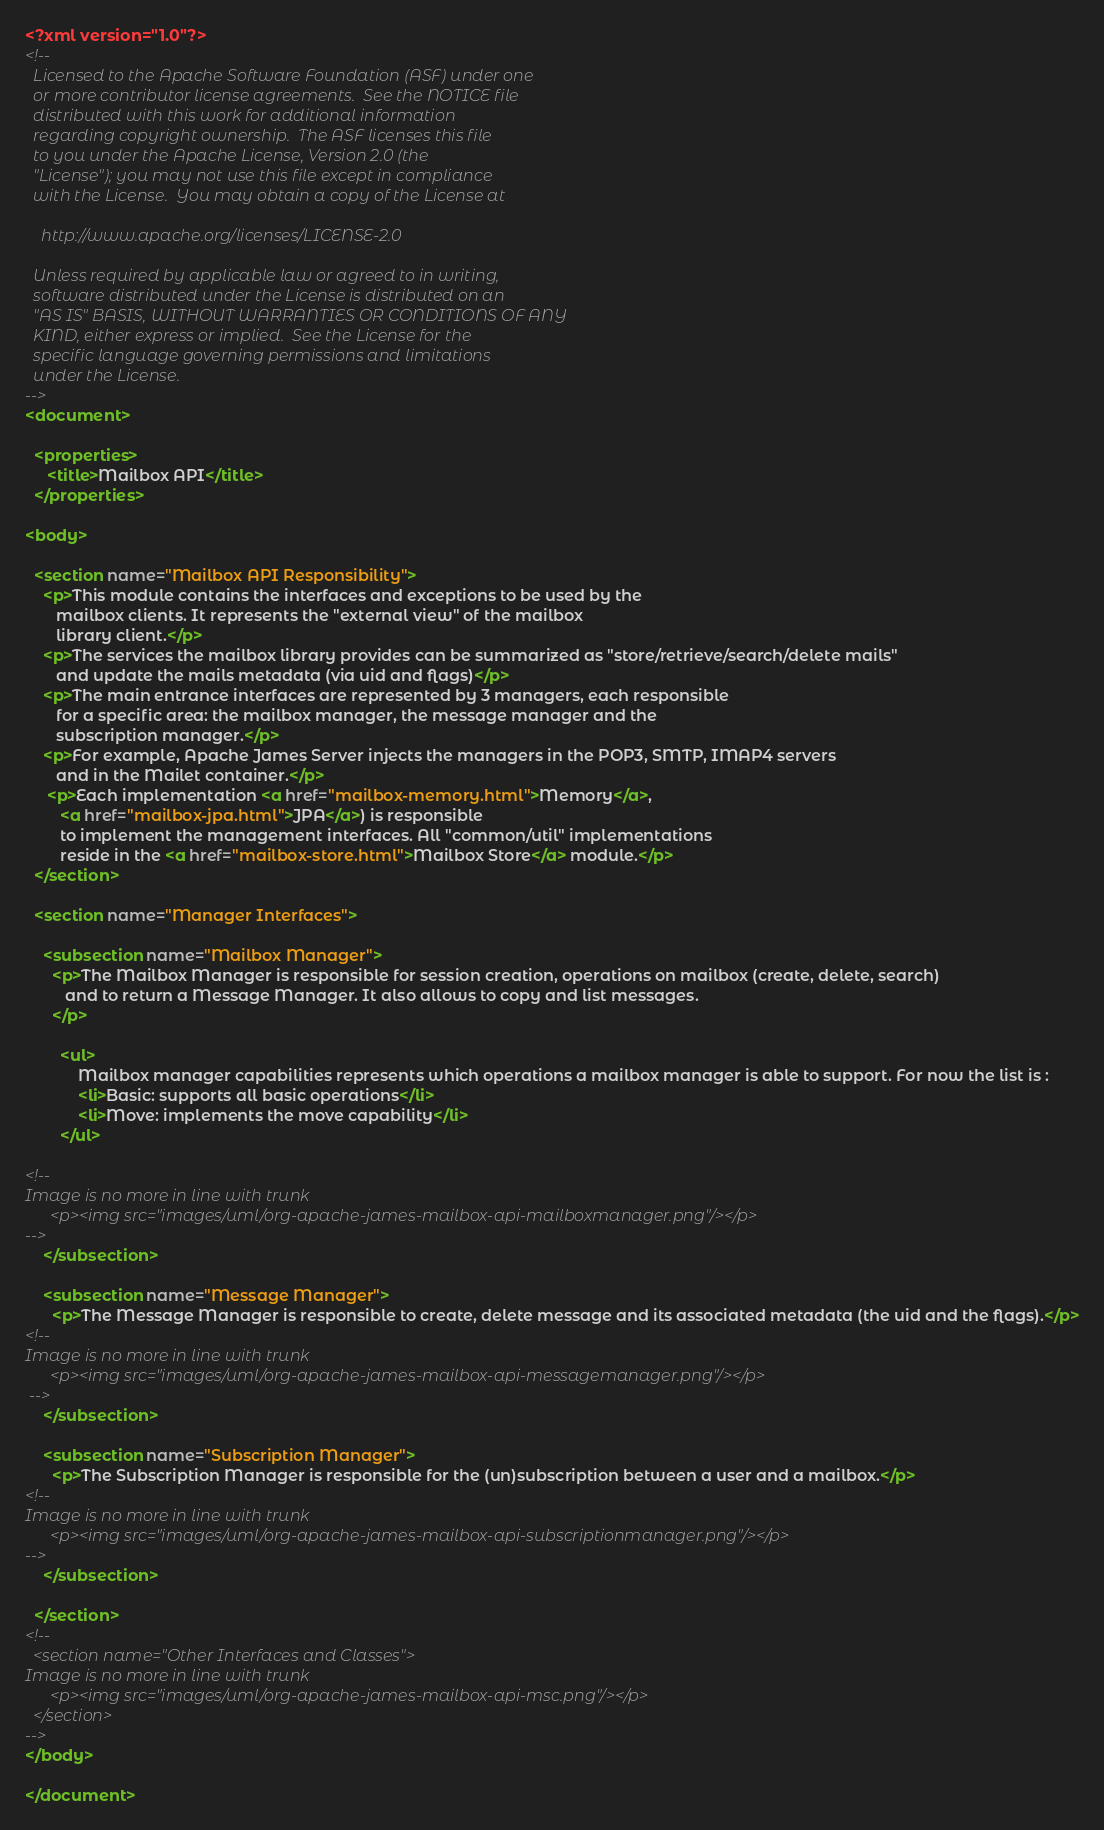<code> <loc_0><loc_0><loc_500><loc_500><_XML_><?xml version="1.0"?>
<!--
  Licensed to the Apache Software Foundation (ASF) under one
  or more contributor license agreements.  See the NOTICE file
  distributed with this work for additional information
  regarding copyright ownership.  The ASF licenses this file
  to you under the Apache License, Version 2.0 (the
  "License"); you may not use this file except in compliance
  with the License.  You may obtain a copy of the License at

    http://www.apache.org/licenses/LICENSE-2.0

  Unless required by applicable law or agreed to in writing,
  software distributed under the License is distributed on an
  "AS IS" BASIS, WITHOUT WARRANTIES OR CONDITIONS OF ANY
  KIND, either express or implied.  See the License for the
  specific language governing permissions and limitations
  under the License.    
-->
<document>

  <properties>
     <title>Mailbox API</title>
  </properties>

<body>

  <section name="Mailbox API Responsibility">
    <p>This module contains the interfaces and exceptions to be used by the 
       mailbox clients. It represents the "external view" of the mailbox
       library client.</p>
    <p>The services the mailbox library provides can be summarized as "store/retrieve/search/delete mails" 
       and update the mails metadata (via uid and flags)</p>
    <p>The main entrance interfaces are represented by 3 managers, each responsible
       for a specific area: the mailbox manager, the message manager and the
       subscription manager.</p>
    <p>For example, Apache James Server injects the managers in the POP3, SMTP, IMAP4 servers
       and in the Mailet container.</p>
     <p>Each implementation <a href="mailbox-memory.html">Memory</a>,
        <a href="mailbox-jpa.html">JPA</a>) is responsible
        to implement the management interfaces. All "common/util" implementations
        reside in the <a href="mailbox-store.html">Mailbox Store</a> module.</p>
  </section>

  <section name="Manager Interfaces">
  
    <subsection name="Mailbox Manager">
      <p>The Mailbox Manager is responsible for session creation, operations on mailbox (create, delete, search)
         and to return a Message Manager. It also allows to copy and list messages.
      </p>

        <ul>
            Mailbox manager capabilities represents which operations a mailbox manager is able to support. For now the list is :
            <li>Basic: supports all basic operations</li>
            <li>Move: implements the move capability</li>
        </ul>

<!-- 
Image is no more in line with trunk
      <p><img src="images/uml/org-apache-james-mailbox-api-mailboxmanager.png"/></p>
-->
    </subsection>
    
    <subsection name="Message Manager">
      <p>The Message Manager is responsible to create, delete message and its associated metadata (the uid and the flags).</p>
<!-- 
Image is no more in line with trunk
      <p><img src="images/uml/org-apache-james-mailbox-api-messagemanager.png"/></p>
 -->
    </subsection>

    <subsection name="Subscription Manager">
      <p>The Subscription Manager is responsible for the (un)subscription between a user and a mailbox.</p>
<!-- 
Image is no more in line with trunk
      <p><img src="images/uml/org-apache-james-mailbox-api-subscriptionmanager.png"/></p>
-->
    </subsection>

  </section>
<!-- 
  <section name="Other Interfaces and Classes">
Image is no more in line with trunk
      <p><img src="images/uml/org-apache-james-mailbox-api-msc.png"/></p>
  </section>
-->
</body>

</document>
</code> 